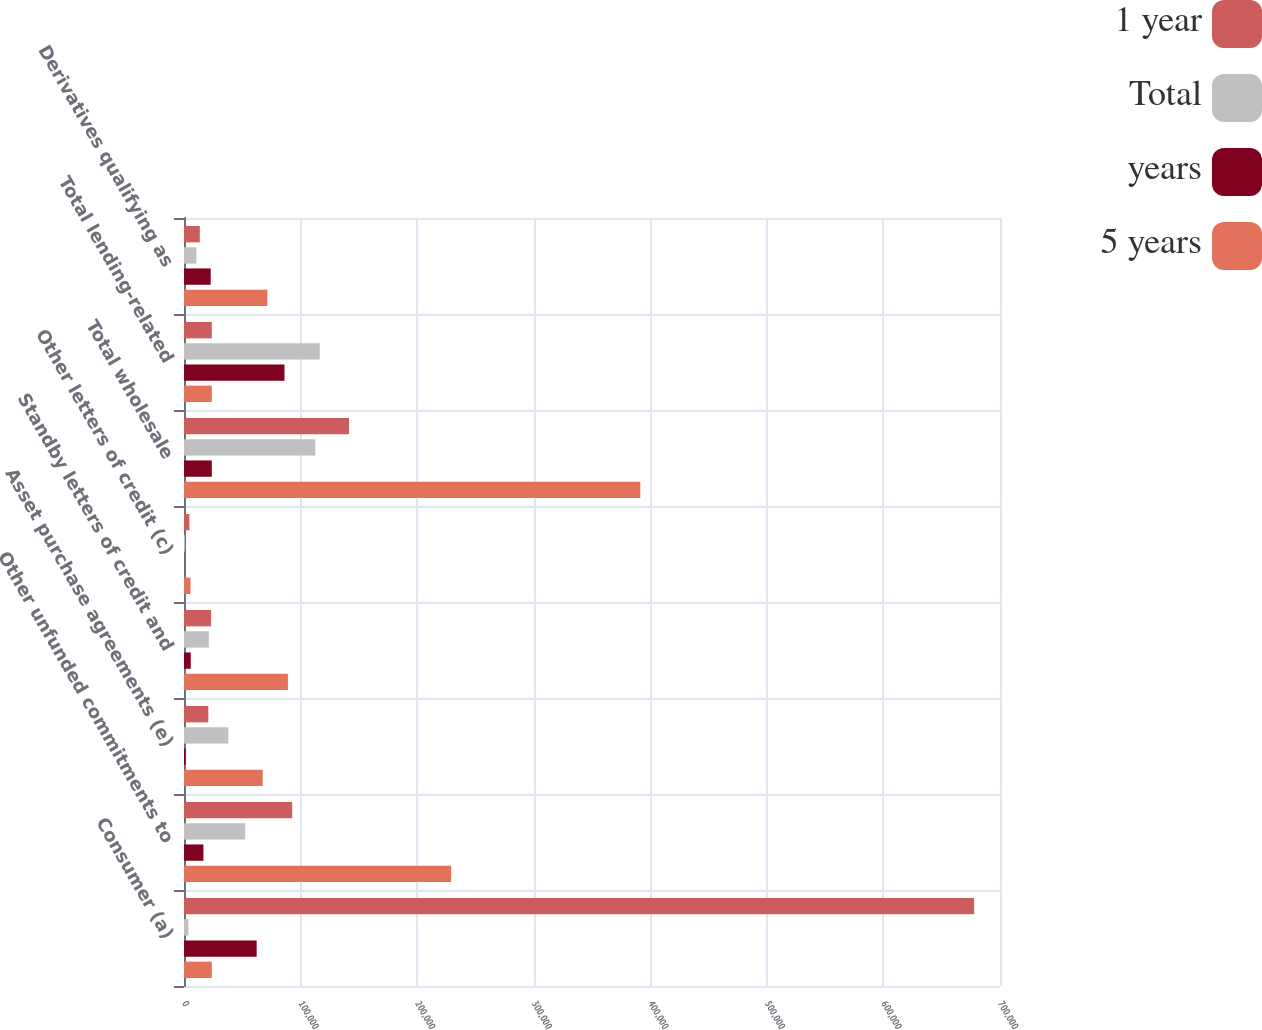<chart> <loc_0><loc_0><loc_500><loc_500><stacked_bar_chart><ecel><fcel>Consumer (a)<fcel>Other unfunded commitments to<fcel>Asset purchase agreements (e)<fcel>Standby letters of credit and<fcel>Other letters of credit (c)<fcel>Total wholesale<fcel>Total lending-related<fcel>Derivatives qualifying as<nl><fcel>1 year<fcel>677784<fcel>92829<fcel>20847<fcel>23264<fcel>4628<fcel>141568<fcel>23862<fcel>13542<nl><fcel>Total<fcel>3807<fcel>52465<fcel>38071<fcel>21286<fcel>823<fcel>112645<fcel>116452<fcel>10656<nl><fcel>years<fcel>62340<fcel>16660<fcel>1425<fcel>5770<fcel>7<fcel>23862<fcel>86202<fcel>22919<nl><fcel>5 years<fcel>23862<fcel>229204<fcel>67529<fcel>89132<fcel>5559<fcel>391424<fcel>23862<fcel>71531<nl></chart> 